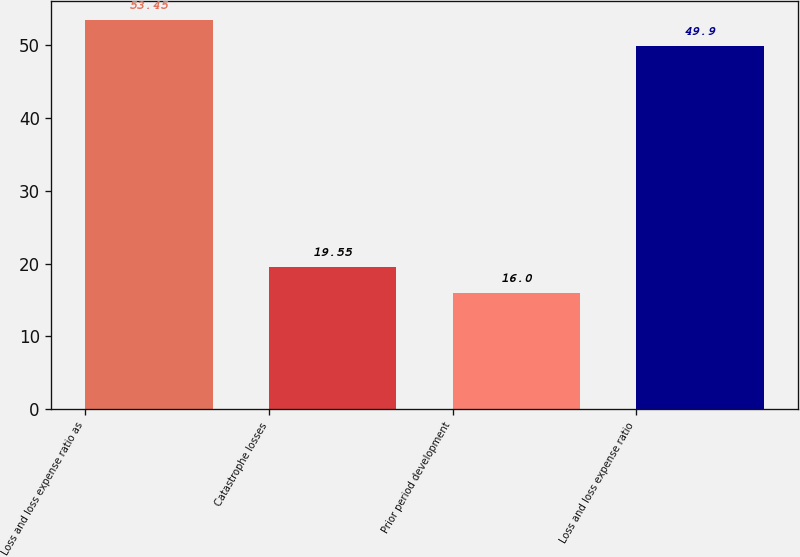Convert chart. <chart><loc_0><loc_0><loc_500><loc_500><bar_chart><fcel>Loss and loss expense ratio as<fcel>Catastrophe losses<fcel>Prior period development<fcel>Loss and loss expense ratio<nl><fcel>53.45<fcel>19.55<fcel>16<fcel>49.9<nl></chart> 